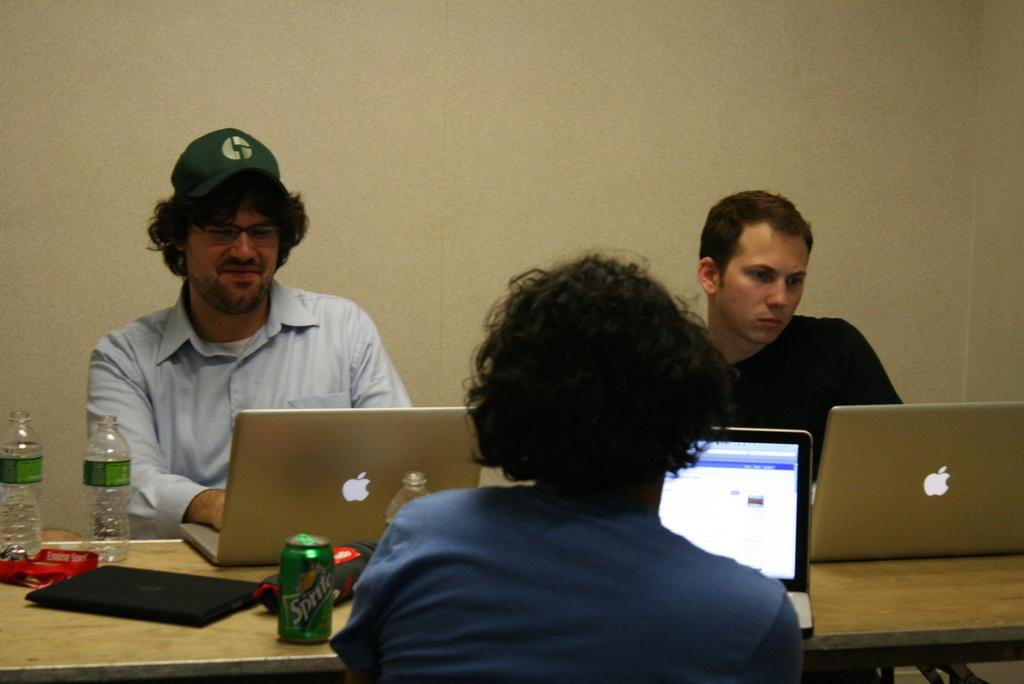How many people are sitting in the image? There are three persons sitting in the image. What electronic device is on the table? There is a laptop on the table. What else is on the table besides the laptop? There is a water bottle and a tin on the table. What can be seen in the background of the image? There is a wall visible in the image. How many frogs are hopping on the table in the image? There are no frogs present in the image; only the three persons, laptop, water bottle, and tin are visible on the table. 